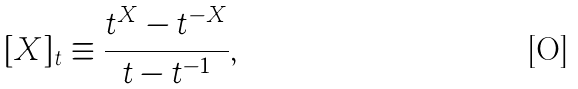<formula> <loc_0><loc_0><loc_500><loc_500>[ X ] _ { t } \equiv \frac { t ^ { X } - t ^ { - X } } { t - t ^ { - 1 } } ,</formula> 